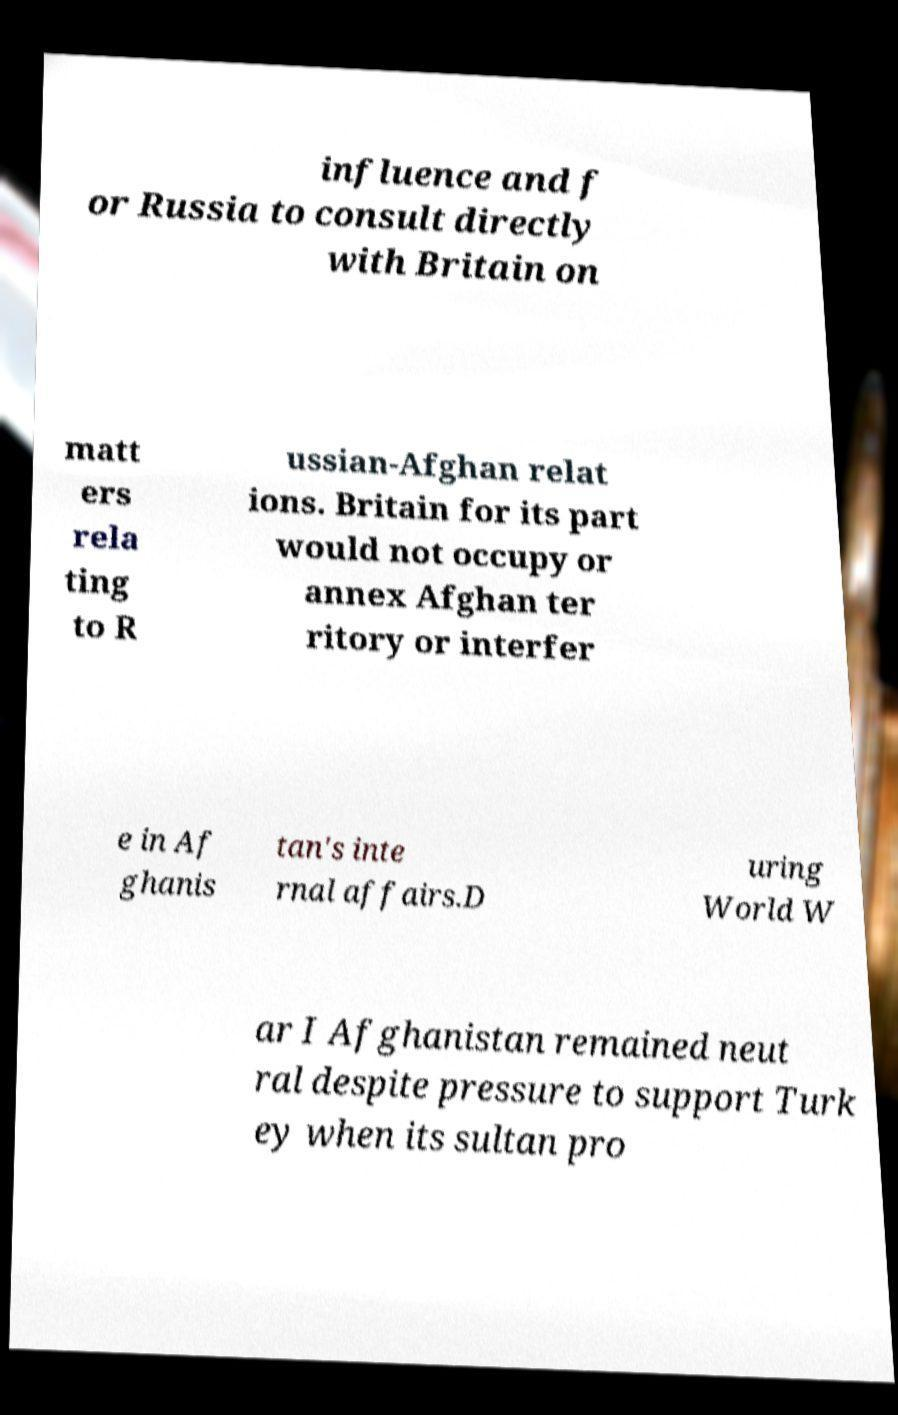There's text embedded in this image that I need extracted. Can you transcribe it verbatim? influence and f or Russia to consult directly with Britain on matt ers rela ting to R ussian-Afghan relat ions. Britain for its part would not occupy or annex Afghan ter ritory or interfer e in Af ghanis tan's inte rnal affairs.D uring World W ar I Afghanistan remained neut ral despite pressure to support Turk ey when its sultan pro 